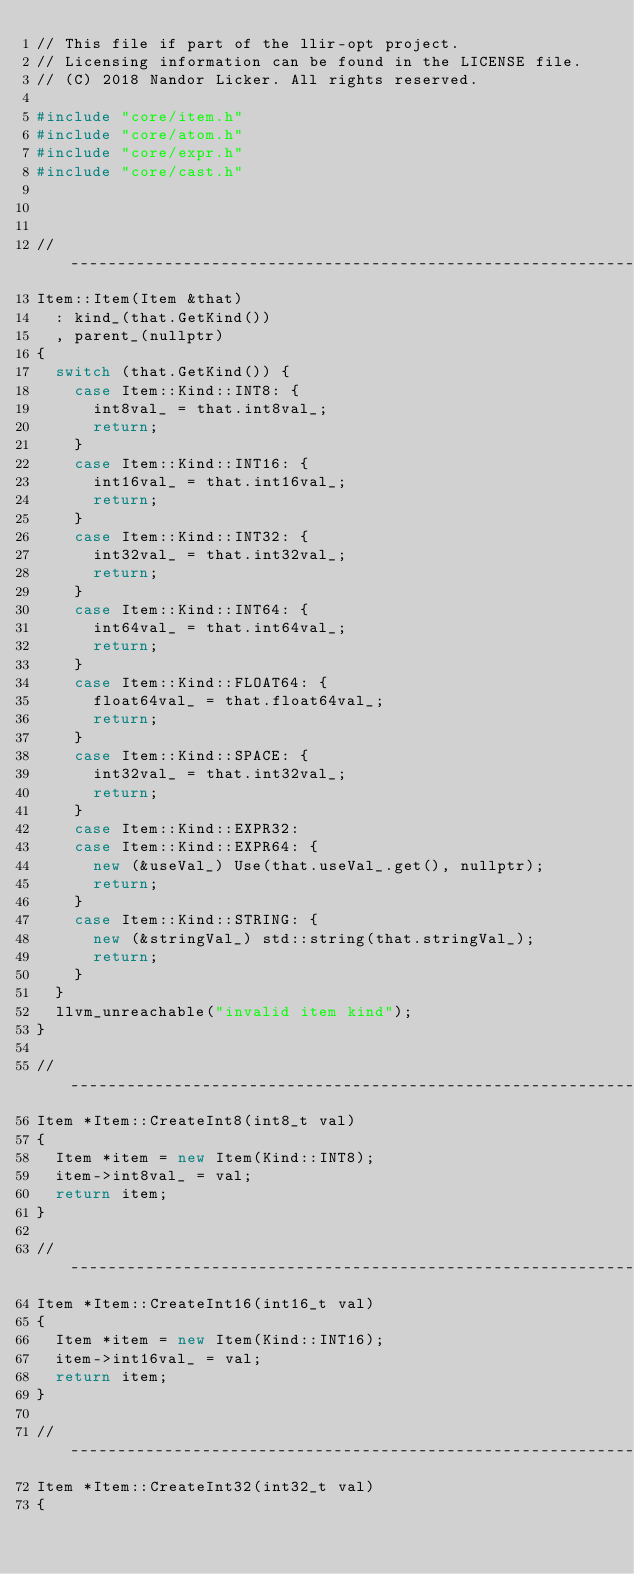<code> <loc_0><loc_0><loc_500><loc_500><_C++_>// This file if part of the llir-opt project.
// Licensing information can be found in the LICENSE file.
// (C) 2018 Nandor Licker. All rights reserved.

#include "core/item.h"
#include "core/atom.h"
#include "core/expr.h"
#include "core/cast.h"



// -----------------------------------------------------------------------------
Item::Item(Item &that)
  : kind_(that.GetKind())
  , parent_(nullptr)
{
  switch (that.GetKind()) {
    case Item::Kind::INT8: {
      int8val_ = that.int8val_;
      return;
    }
    case Item::Kind::INT16: {
      int16val_ = that.int16val_;
      return;
    }
    case Item::Kind::INT32: {
      int32val_ = that.int32val_;
      return;
    }
    case Item::Kind::INT64: {
      int64val_ = that.int64val_;
      return;
    }
    case Item::Kind::FLOAT64: {
      float64val_ = that.float64val_;
      return;
    }
    case Item::Kind::SPACE: {
      int32val_ = that.int32val_;
      return;
    }
    case Item::Kind::EXPR32:
    case Item::Kind::EXPR64: {
      new (&useVal_) Use(that.useVal_.get(), nullptr);
      return;
    }
    case Item::Kind::STRING: {
      new (&stringVal_) std::string(that.stringVal_);
      return;
    }
  }
  llvm_unreachable("invalid item kind");
}

// -----------------------------------------------------------------------------
Item *Item::CreateInt8(int8_t val)
{
  Item *item = new Item(Kind::INT8);
  item->int8val_ = val;
  return item;
}

// -----------------------------------------------------------------------------
Item *Item::CreateInt16(int16_t val)
{
  Item *item = new Item(Kind::INT16);
  item->int16val_ = val;
  return item;
}

// -----------------------------------------------------------------------------
Item *Item::CreateInt32(int32_t val)
{</code> 